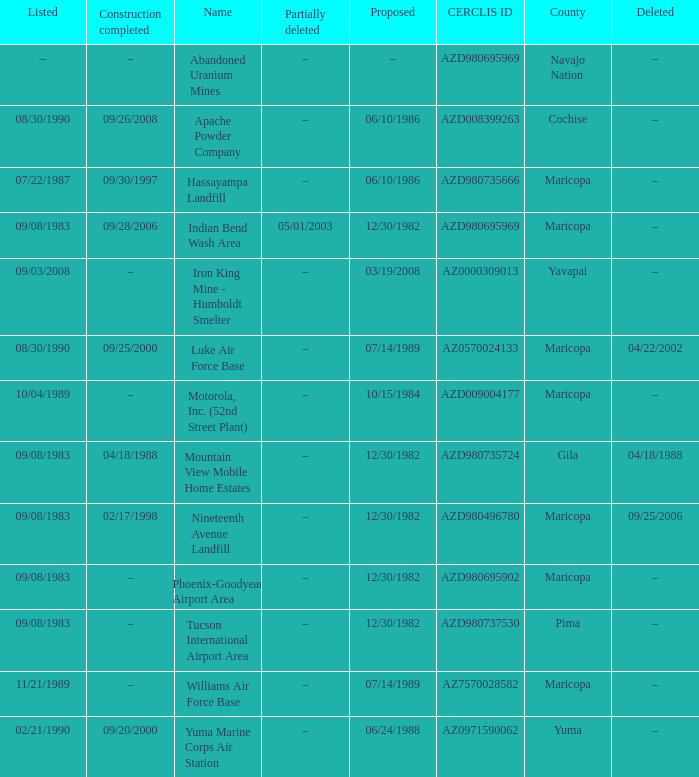When was the site partially deleted when the cerclis id is az7570028582? –. 